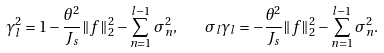Convert formula to latex. <formula><loc_0><loc_0><loc_500><loc_500>\gamma _ { l } ^ { 2 } = 1 - \frac { \theta ^ { 2 } } { J _ { s } } \| f \| _ { 2 } ^ { 2 } - \sum _ { n = 1 } ^ { l - 1 } \sigma _ { n } ^ { 2 } , \quad \sigma _ { l } \gamma _ { l } = - \frac { \theta ^ { 2 } } { J _ { s } } \| f \| _ { 2 } ^ { 2 } - \sum _ { n = 1 } ^ { l - 1 } \sigma _ { n } ^ { 2 } .</formula> 